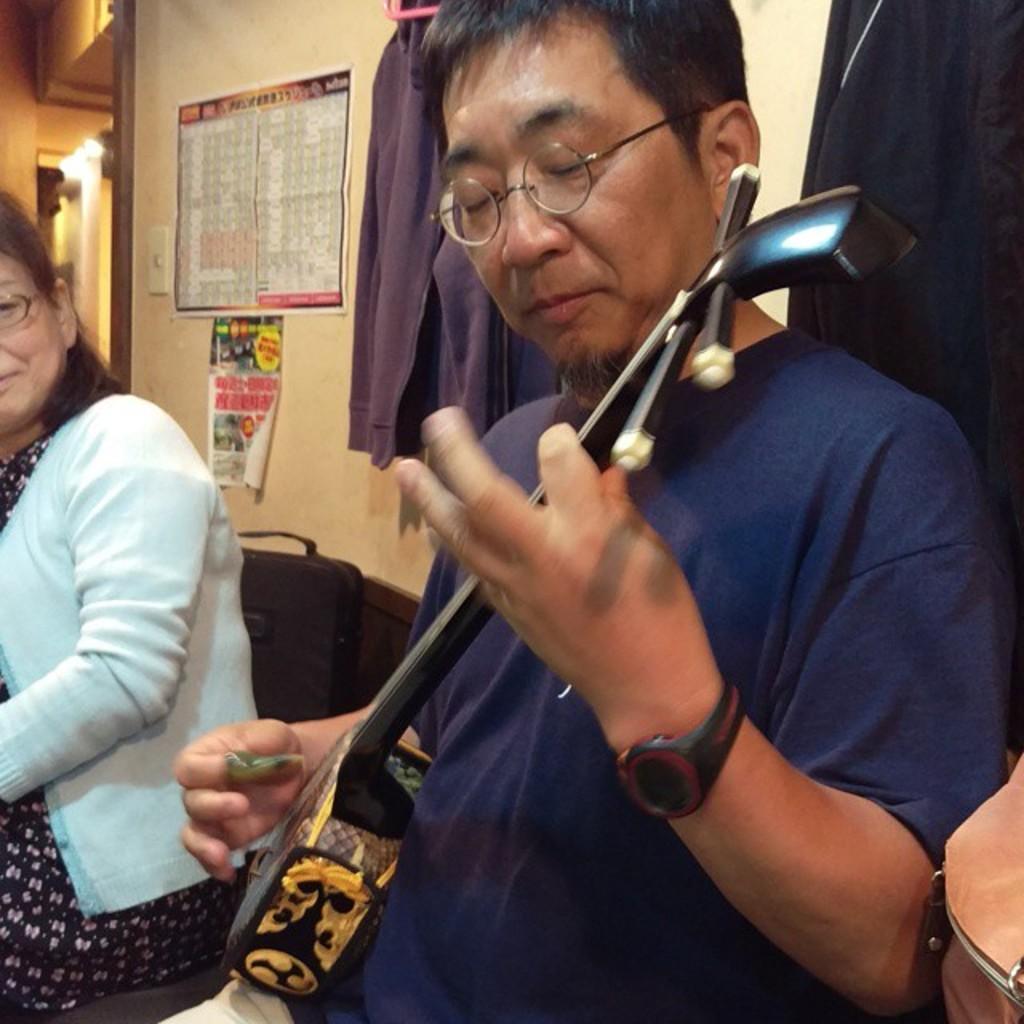Can you describe this image briefly? In this picture there is a man wearing blue color t-shirt is playing a small guitar. Beside there is a woman wearing a white color sweater is sitting and looking to him. Behind there is a yellow color wall. 